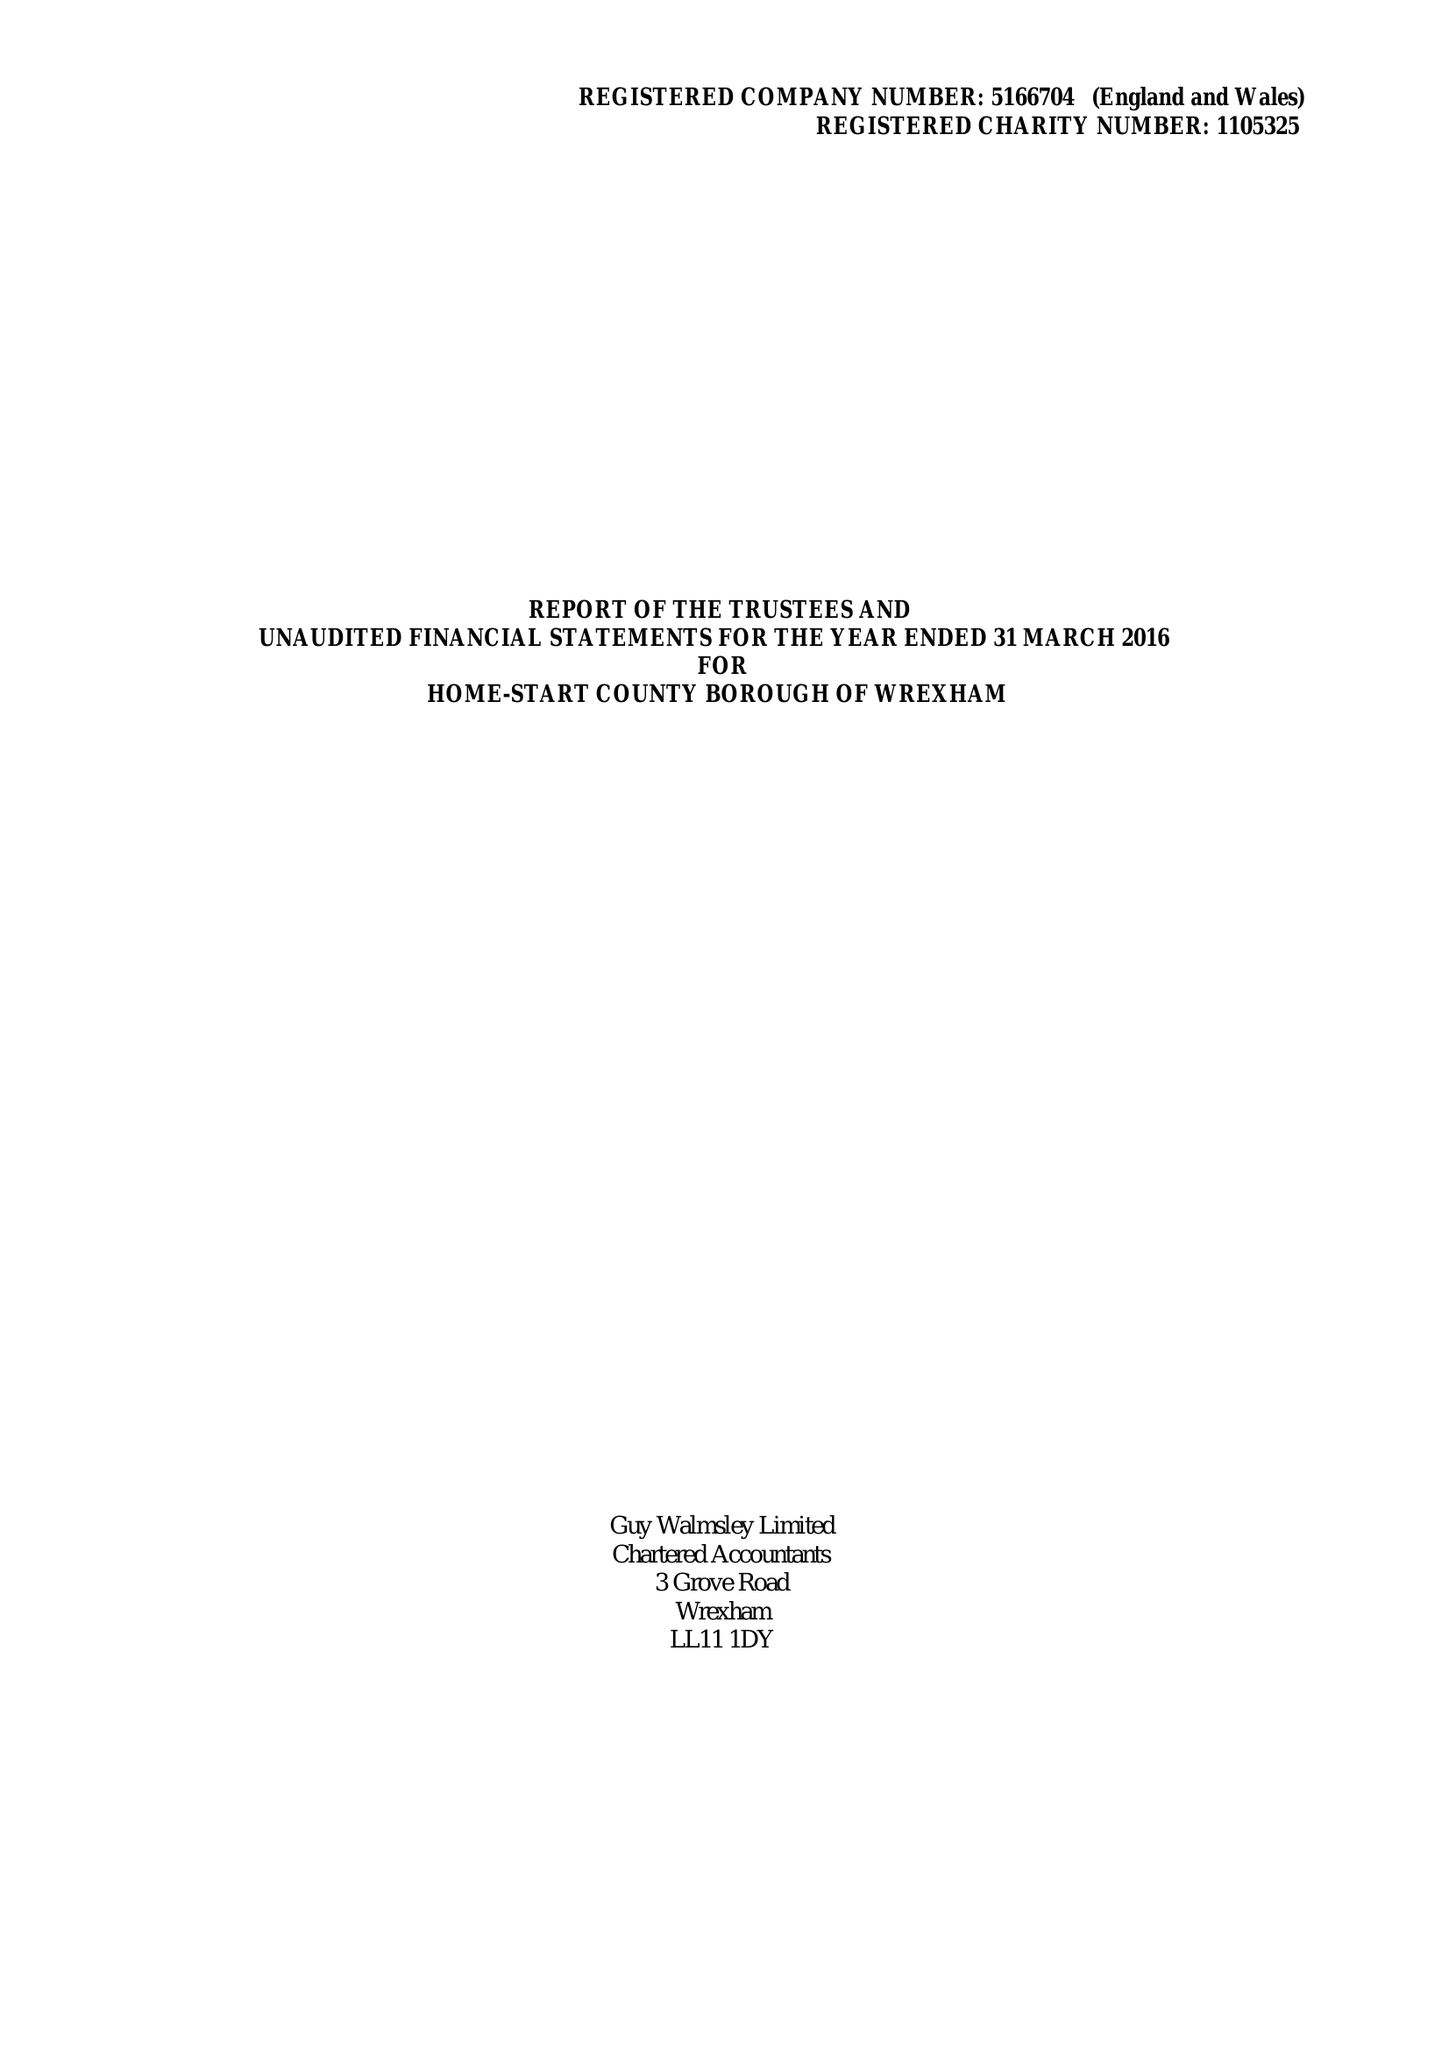What is the value for the charity_number?
Answer the question using a single word or phrase. 1105325 